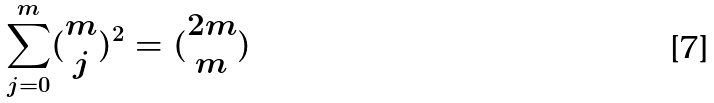<formula> <loc_0><loc_0><loc_500><loc_500>\sum _ { j = 0 } ^ { m } ( \begin{matrix} m \\ j \end{matrix} ) ^ { 2 } = ( \begin{matrix} 2 m \\ m \end{matrix} )</formula> 